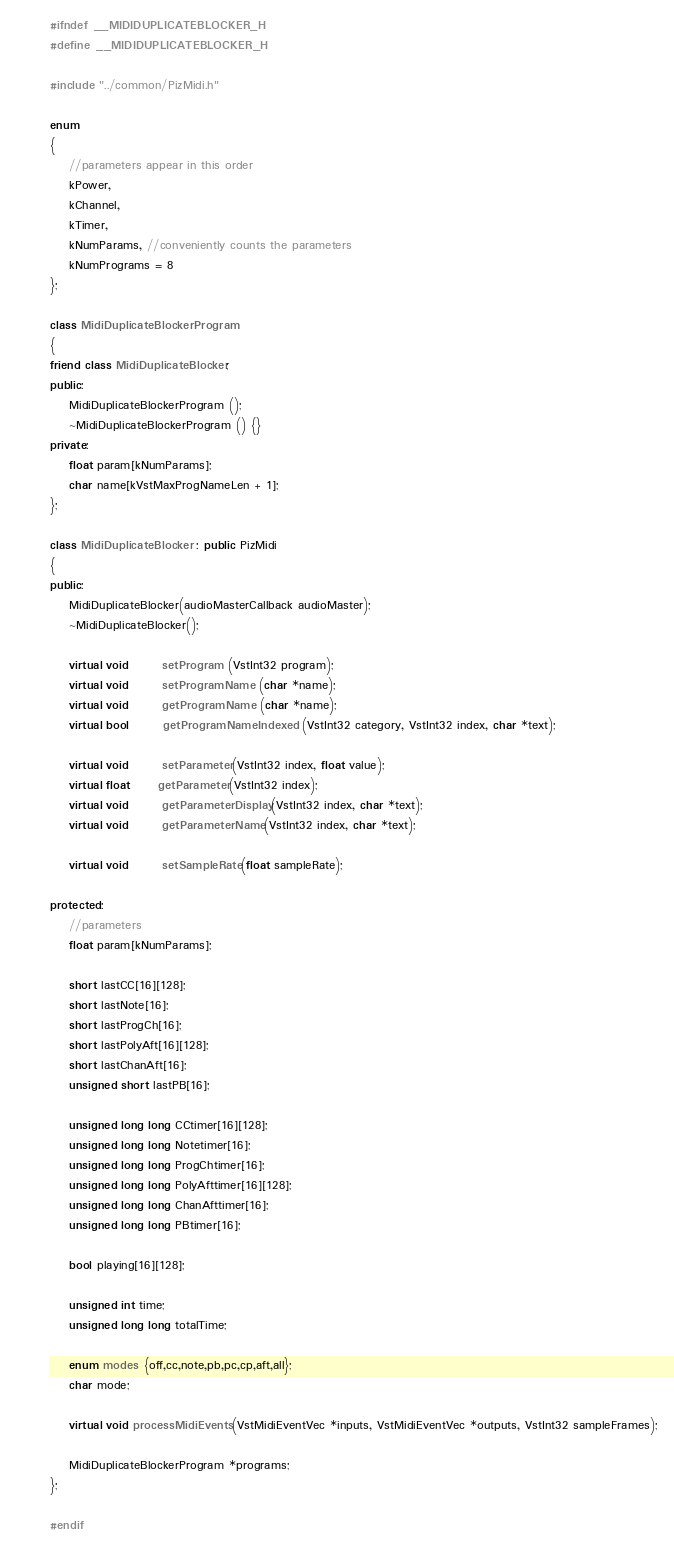<code> <loc_0><loc_0><loc_500><loc_500><_C++_>#ifndef __MIDIDUPLICATEBLOCKER_H
#define __MIDIDUPLICATEBLOCKER_H

#include "../common/PizMidi.h"

enum
{
    //parameters appear in this order
    kPower,
	kChannel,
    kTimer,
	kNumParams, //conveniently counts the parameters
    kNumPrograms = 8
};      

class MidiDuplicateBlockerProgram 
{	
friend class MidiDuplicateBlocker;
public:
	MidiDuplicateBlockerProgram ();
	~MidiDuplicateBlockerProgram () {}
private:
    float param[kNumParams];
	char name[kVstMaxProgNameLen + 1];
};

class MidiDuplicateBlocker : public PizMidi
{
public:
	MidiDuplicateBlocker(audioMasterCallback audioMaster);
	~MidiDuplicateBlocker();

	virtual void       setProgram (VstInt32 program);
	virtual void       setProgramName (char *name);
	virtual void       getProgramName (char *name);
	virtual bool       getProgramNameIndexed (VstInt32 category, VstInt32 index, char *text);
	
	virtual void       setParameter(VstInt32 index, float value);
    virtual float      getParameter(VstInt32 index);
	virtual void       getParameterDisplay(VstInt32 index, char *text);
	virtual void       getParameterName(VstInt32 index, char *text);
	
	virtual void       setSampleRate(float sampleRate);

protected:
    //parameters
    float param[kNumParams];
	
	short lastCC[16][128];
	short lastNote[16];
	short lastProgCh[16];
	short lastPolyAft[16][128];
	short lastChanAft[16];
	unsigned short lastPB[16];

	unsigned long long CCtimer[16][128];
	unsigned long long Notetimer[16];
	unsigned long long ProgChtimer[16];
	unsigned long long PolyAfttimer[16][128];
	unsigned long long ChanAfttimer[16];
	unsigned long long PBtimer[16];

	bool playing[16][128];

    unsigned int time;
    unsigned long long totalTime;

	enum modes {off,cc,note,pb,pc,cp,aft,all};
	char mode;

	virtual void processMidiEvents(VstMidiEventVec *inputs, VstMidiEventVec *outputs, VstInt32 sampleFrames);
	
   	MidiDuplicateBlockerProgram *programs;
};

#endif
</code> 